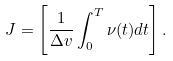<formula> <loc_0><loc_0><loc_500><loc_500>J = \left [ \frac { 1 } { \Delta { v } } \int _ { 0 } ^ { T } \nu ( t ) d t \right ] .</formula> 